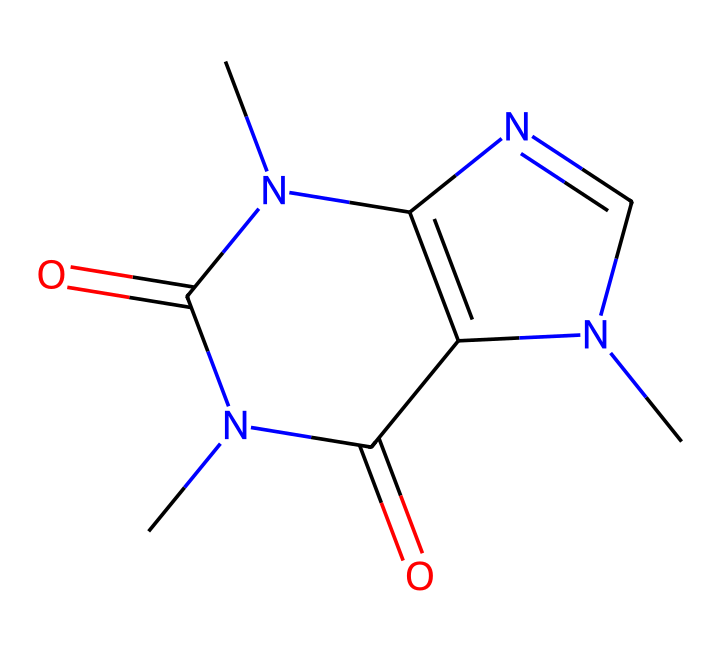What is the molecular formula of caffeine? The molecular formula can be derived from the SMILES representation. Counting the atoms, we identify 8 carbons (C), 10 hydrogens (H), 4 nitrogens (N), and 2 oxygens (O). Therefore, the molecular formula is C8H10N4O2.
Answer: C8H10N4O2 How many nitrogen atoms are present in caffeine? By examining the SMILES representation, we can see that there are four nitrogen atoms (N) present in the chemical structure.
Answer: four What type of functional groups are present in caffeine? Analyzing the structure reveals that caffeine contains amine groups (-NH) and carbonyl groups (C=O) as its functional groups.
Answer: amine and carbonyl What is the IUPAC name of caffeine? Caffeine is widely recognized, and its IUPAC name is 1,3,7-trimethylxanthine, which can be confirmed by analyzing the structure and identifying its specific attributes.
Answer: 1,3,7-trimethylxanthine Which part of the caffeine structure contributes to its stimulant properties? The presence of nitrogen atoms in a specific arrangement, particularly in the xanthine ring, is characteristic of many stimulants, which includes caffeine.
Answer: xanthine ring How many rings are found in the caffeine structure? By closely observing the chemical structure, there are two fused rings present in the caffeine molecule, contributing to its complexity and activity.
Answer: two What is the common source of caffeine in beverages? Caffeine is predominantly sourced from coffee beans, which is a well-known fact among consumers of caffeinated beverages.
Answer: coffee beans 